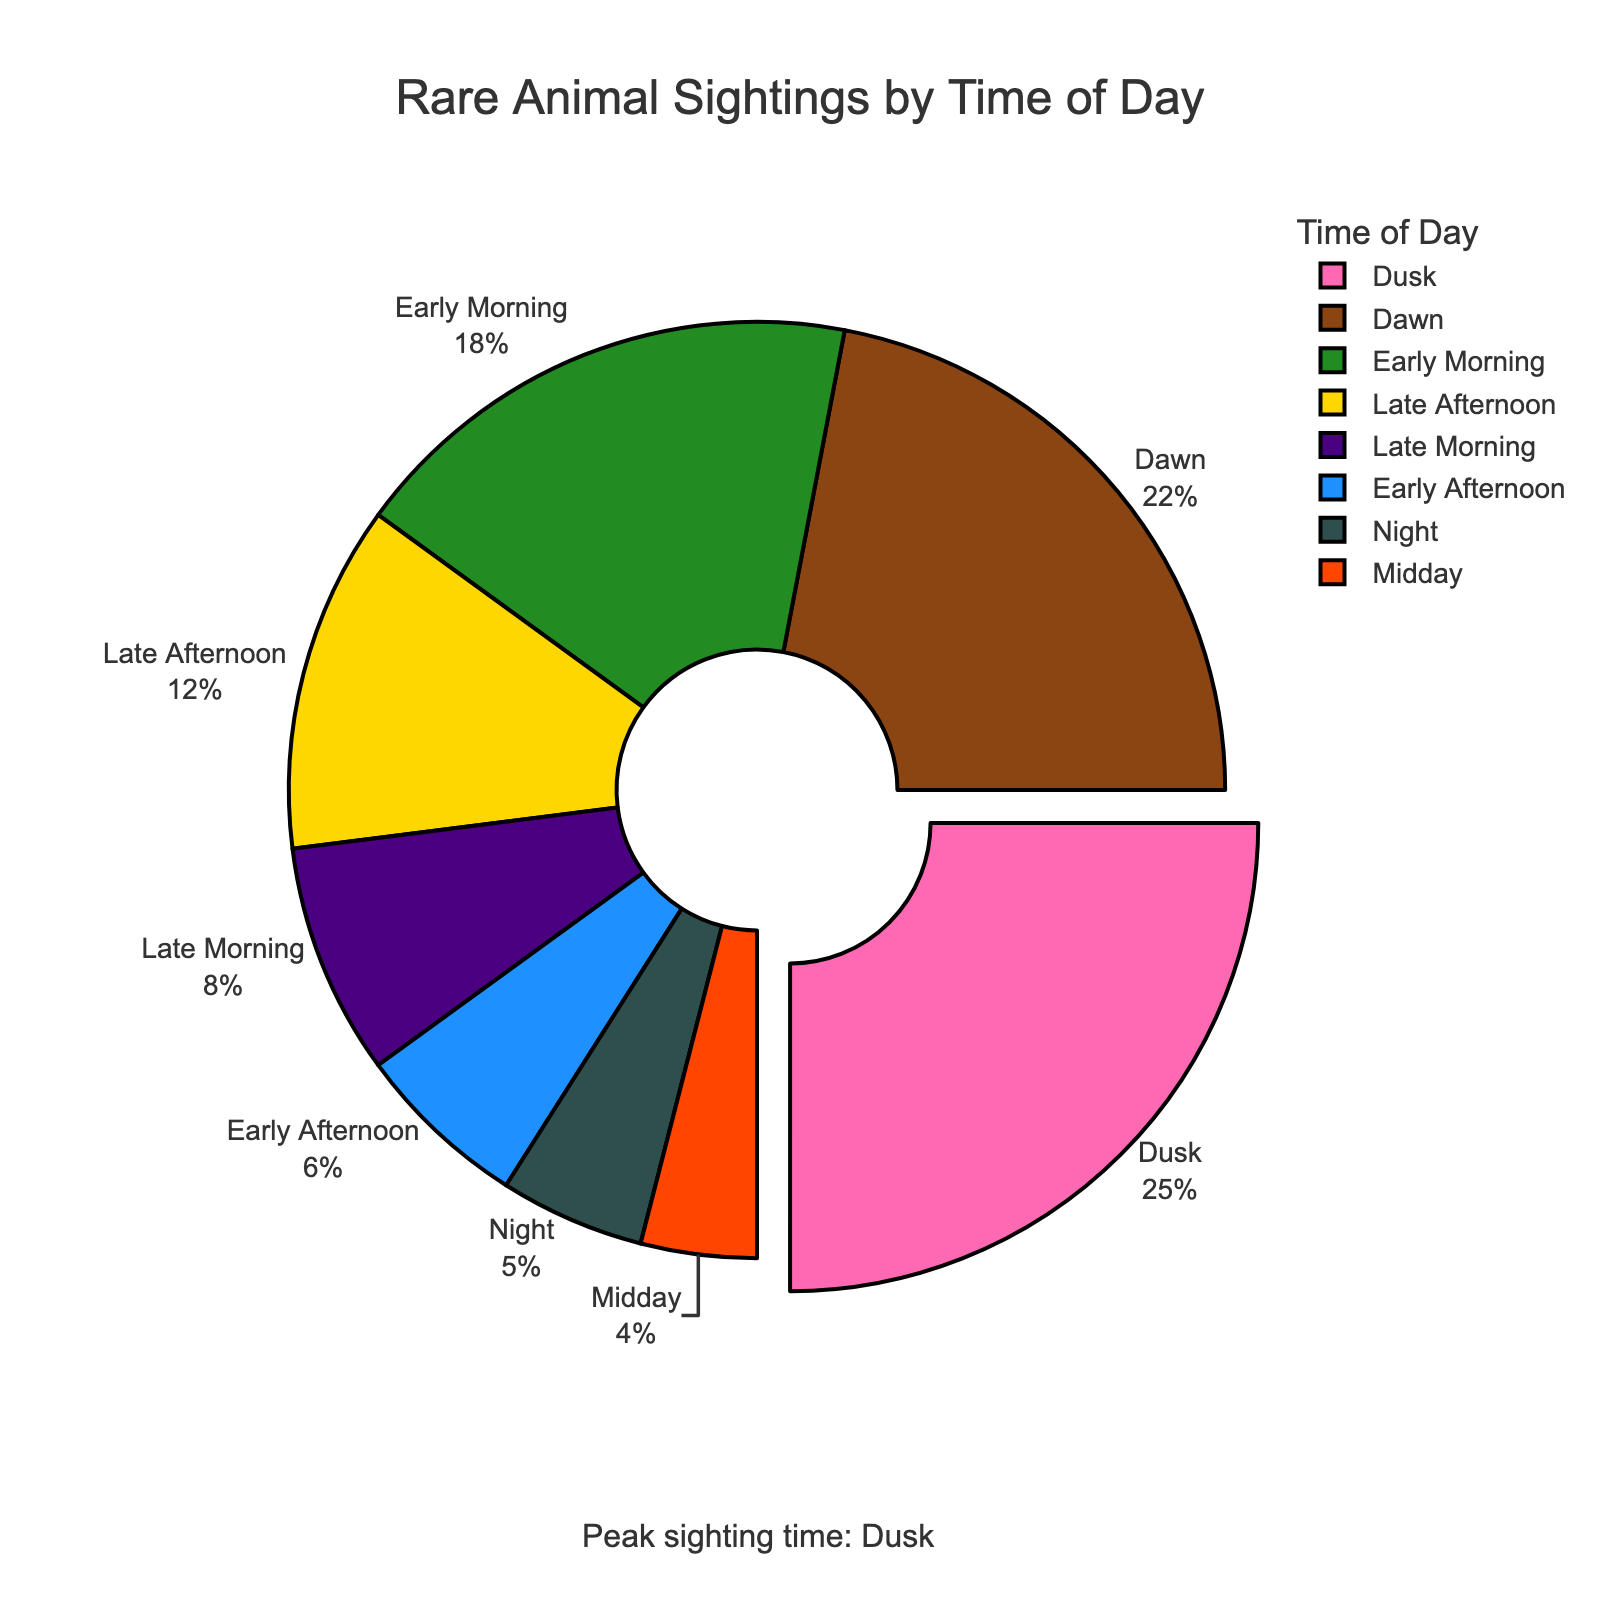What's the percentage of sightings at Dusk compared to Early Morning? The percentage of sightings at Dusk is 25%, while Early Morning is 18%. To compare, subtract the Early Morning percentage from the Dusk percentage which is 25% - 18% = 7%.
Answer: 7% Which time of day has the fewest sightings and what is the percentage? The percentage values for each time of day are shown in the chart. The Midday has the fewest sightings with a percentage of 4%.
Answer: Midday, 4% Add the percentages for Dawn and Dusk sightings. What do you get? The percentage for Dawn is 22% and for Dusk is 25%. Sum them up: 22% + 25% = 47%.
Answer: 47% What percentage of sightings occur between Late Afternoon and Midnight? The percentages for Late Afternoon, Dusk, and Night are 12%, 25%, and 5%, respectively. Sum them up: 12% + 25% + 5% = 42%.
Answer: 42% Are there more sightings at Dawn or Early Afternoon? By how much? The percentage of sightings at Dawn is 22% and at Early Afternoon is 6%. Subtract the Early Afternoon percentage from the Dawn percentage: 22% - 6% = 16%.
Answer: Dawn, 16% Which time of day is highlighted or pulled out in the chart, and why? Dusk is highlighted or pulled out, indicating it has the peak sighting time.
Answer: Dusk What is the combined percentage of sightings during Early Morning and Late Afternoon? The percentage of sightings during Early Morning is 18% and during Late Afternoon is 12%. Sum them up: 18% + 12% = 30%.
Answer: 30% What can you say about the sightings at Night compared to Midday? The percentage of Night sightings is 5% which is slightly higher than Midday at 4%. Hence, Night has more sightings by 1%.
Answer: Slightly more at Night, 1% 